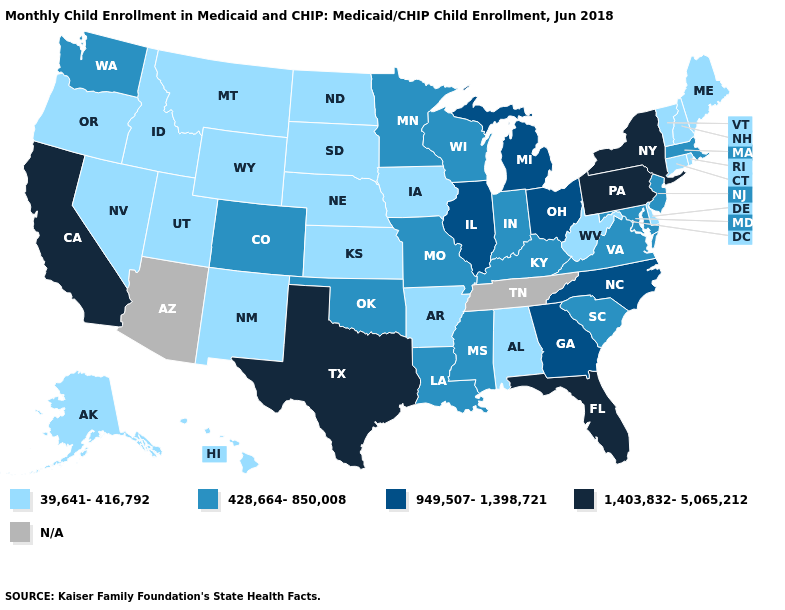Name the states that have a value in the range 428,664-850,008?
Concise answer only. Colorado, Indiana, Kentucky, Louisiana, Maryland, Massachusetts, Minnesota, Mississippi, Missouri, New Jersey, Oklahoma, South Carolina, Virginia, Washington, Wisconsin. Does the map have missing data?
Short answer required. Yes. What is the highest value in the USA?
Give a very brief answer. 1,403,832-5,065,212. Which states have the lowest value in the USA?
Give a very brief answer. Alabama, Alaska, Arkansas, Connecticut, Delaware, Hawaii, Idaho, Iowa, Kansas, Maine, Montana, Nebraska, Nevada, New Hampshire, New Mexico, North Dakota, Oregon, Rhode Island, South Dakota, Utah, Vermont, West Virginia, Wyoming. Does Colorado have the lowest value in the USA?
Keep it brief. No. Does California have the lowest value in the West?
Concise answer only. No. Among the states that border Oklahoma , which have the highest value?
Short answer required. Texas. What is the lowest value in the USA?
Give a very brief answer. 39,641-416,792. Name the states that have a value in the range 1,403,832-5,065,212?
Answer briefly. California, Florida, New York, Pennsylvania, Texas. What is the value of Georgia?
Answer briefly. 949,507-1,398,721. Does Washington have the highest value in the USA?
Write a very short answer. No. What is the lowest value in the West?
Give a very brief answer. 39,641-416,792. Which states have the lowest value in the MidWest?
Keep it brief. Iowa, Kansas, Nebraska, North Dakota, South Dakota. Name the states that have a value in the range N/A?
Be succinct. Arizona, Tennessee. Among the states that border Florida , which have the highest value?
Give a very brief answer. Georgia. 